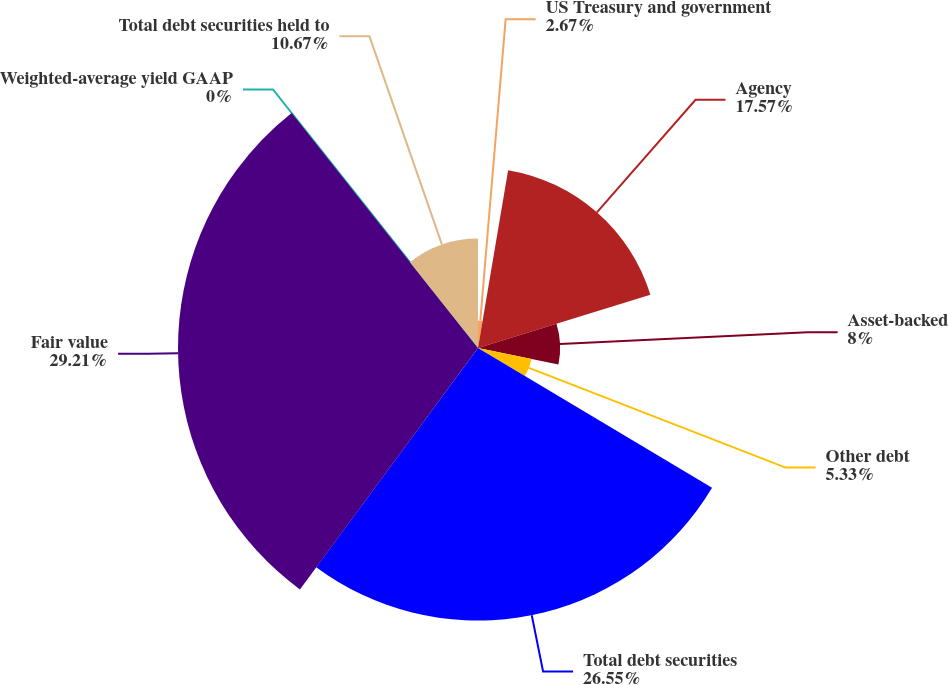<chart> <loc_0><loc_0><loc_500><loc_500><pie_chart><fcel>US Treasury and government<fcel>Agency<fcel>Asset-backed<fcel>Other debt<fcel>Total debt securities<fcel>Fair value<fcel>Weighted-average yield GAAP<fcel>Total debt securities held to<nl><fcel>2.67%<fcel>17.57%<fcel>8.0%<fcel>5.33%<fcel>26.55%<fcel>29.22%<fcel>0.0%<fcel>10.67%<nl></chart> 